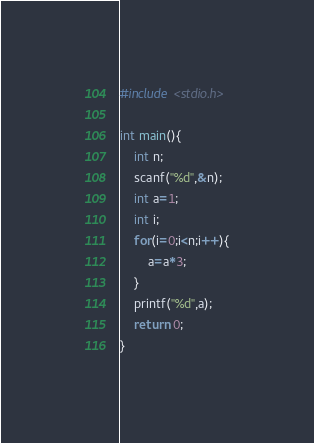<code> <loc_0><loc_0><loc_500><loc_500><_C_>#include <stdio.h>

int main(){
    int n;
    scanf("%d",&n);
    int a=1;
    int i;
    for(i=0;i<n;i++){
        a=a*3;
    }
    printf("%d",a);
    return 0;
}</code> 